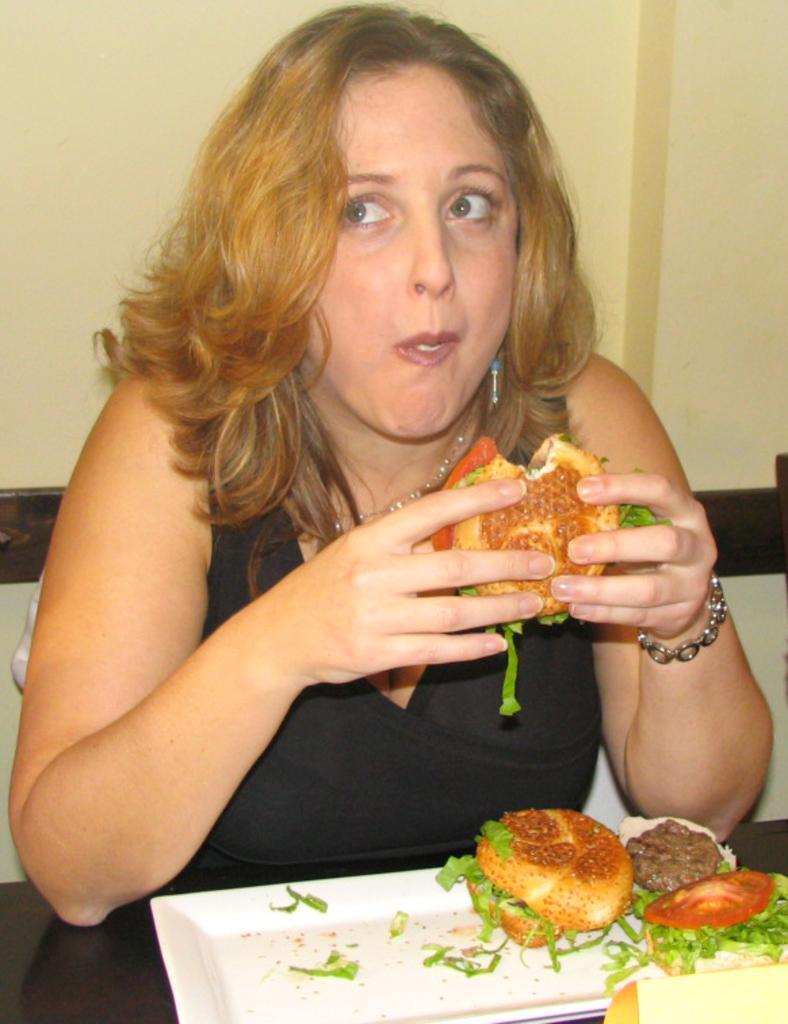How would you summarize this image in a sentence or two? In this image there is a person eating burger. There is another burger on the plate. There is a wall in the back side. 